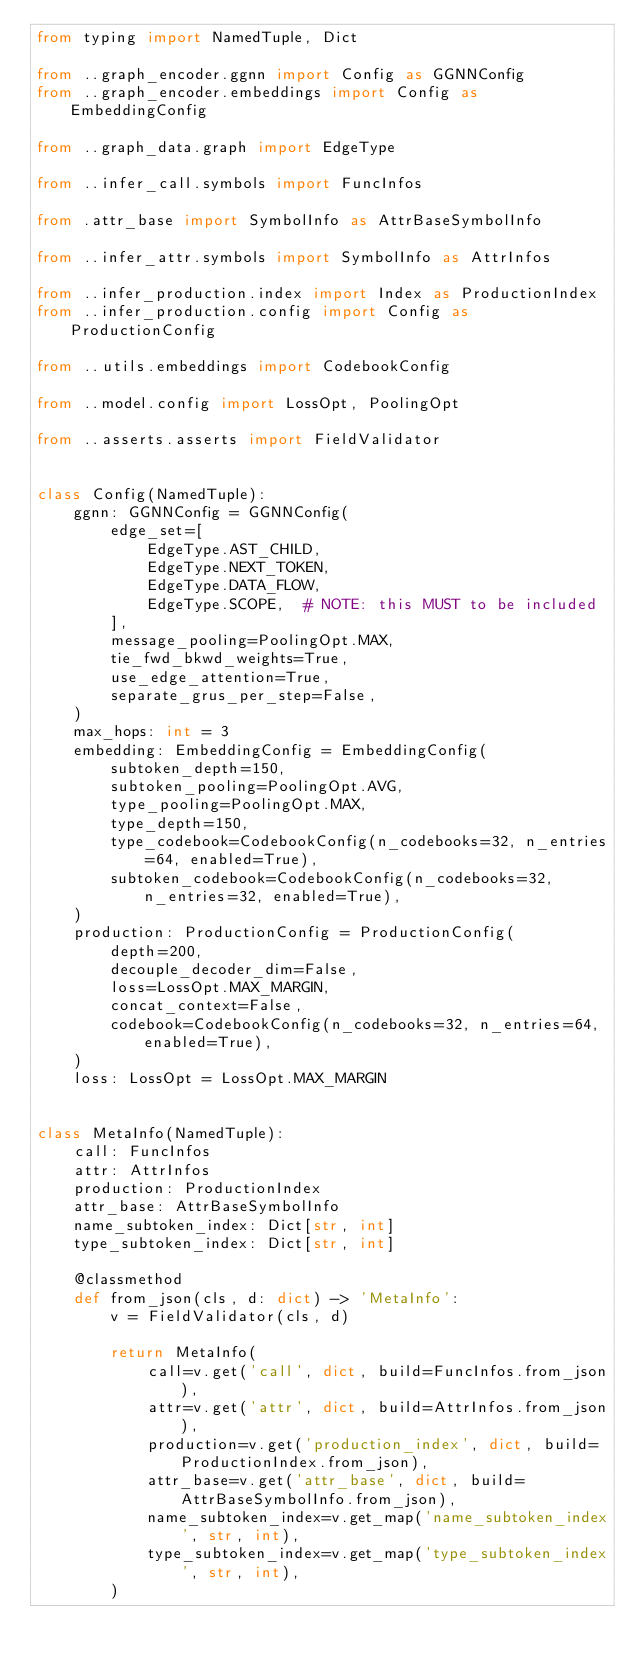<code> <loc_0><loc_0><loc_500><loc_500><_Python_>from typing import NamedTuple, Dict

from ..graph_encoder.ggnn import Config as GGNNConfig
from ..graph_encoder.embeddings import Config as EmbeddingConfig

from ..graph_data.graph import EdgeType

from ..infer_call.symbols import FuncInfos

from .attr_base import SymbolInfo as AttrBaseSymbolInfo

from ..infer_attr.symbols import SymbolInfo as AttrInfos

from ..infer_production.index import Index as ProductionIndex
from ..infer_production.config import Config as ProductionConfig

from ..utils.embeddings import CodebookConfig

from ..model.config import LossOpt, PoolingOpt

from ..asserts.asserts import FieldValidator


class Config(NamedTuple):
    ggnn: GGNNConfig = GGNNConfig(
        edge_set=[
            EdgeType.AST_CHILD,
            EdgeType.NEXT_TOKEN,
            EdgeType.DATA_FLOW,
            EdgeType.SCOPE,  # NOTE: this MUST to be included
        ],
        message_pooling=PoolingOpt.MAX,
        tie_fwd_bkwd_weights=True,
        use_edge_attention=True,
        separate_grus_per_step=False,
    )
    max_hops: int = 3
    embedding: EmbeddingConfig = EmbeddingConfig(
        subtoken_depth=150,
        subtoken_pooling=PoolingOpt.AVG,
        type_pooling=PoolingOpt.MAX,
        type_depth=150,
        type_codebook=CodebookConfig(n_codebooks=32, n_entries=64, enabled=True),
        subtoken_codebook=CodebookConfig(n_codebooks=32, n_entries=32, enabled=True),
    )
    production: ProductionConfig = ProductionConfig(
        depth=200,
        decouple_decoder_dim=False,
        loss=LossOpt.MAX_MARGIN,
        concat_context=False,
        codebook=CodebookConfig(n_codebooks=32, n_entries=64, enabled=True),
    )
    loss: LossOpt = LossOpt.MAX_MARGIN


class MetaInfo(NamedTuple):
    call: FuncInfos
    attr: AttrInfos
    production: ProductionIndex
    attr_base: AttrBaseSymbolInfo
    name_subtoken_index: Dict[str, int]
    type_subtoken_index: Dict[str, int]

    @classmethod
    def from_json(cls, d: dict) -> 'MetaInfo':
        v = FieldValidator(cls, d)

        return MetaInfo(
            call=v.get('call', dict, build=FuncInfos.from_json),
            attr=v.get('attr', dict, build=AttrInfos.from_json),
            production=v.get('production_index', dict, build=ProductionIndex.from_json),
            attr_base=v.get('attr_base', dict, build=AttrBaseSymbolInfo.from_json),
            name_subtoken_index=v.get_map('name_subtoken_index', str, int),
            type_subtoken_index=v.get_map('type_subtoken_index', str, int),
        )
</code> 